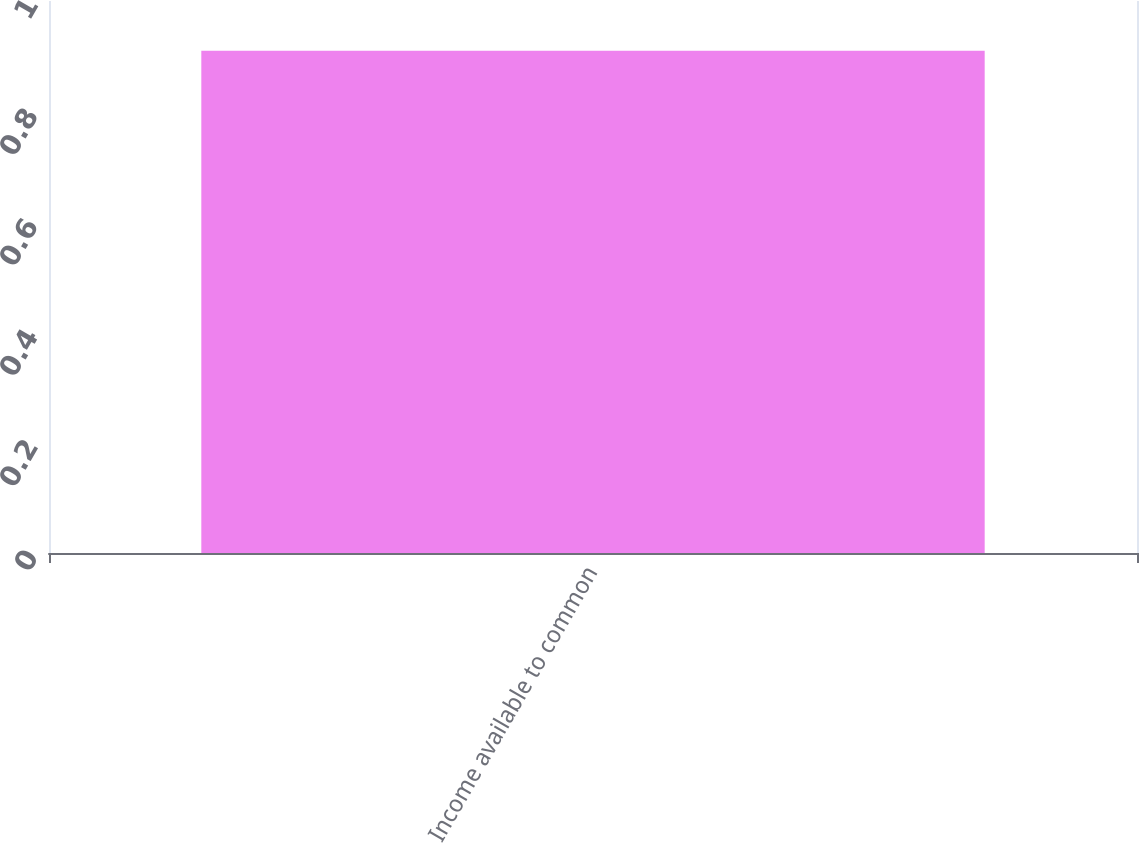Convert chart. <chart><loc_0><loc_0><loc_500><loc_500><bar_chart><fcel>Income available to common<nl><fcel>0.91<nl></chart> 